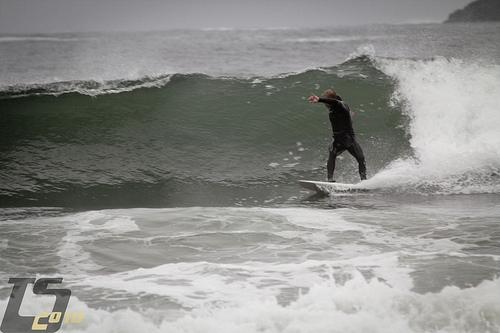What color is the surfboard that the man is standing on? The surfboard is white in color. Find the aspect of the scene that might hold a deeper meaning or emotion in a visual analysis task. The rough ocean water and white water on the waves signify the power and unpredictability of nature, challenging the surfer to find the perfect balance and control. Establish a connection between the main subject and their environment for a story scene setting. A blond man in a black wetsuit expertly riding a large ocean wave on his white surfboard, with the land in the distance and grey skies overhead. Tell a story inspired by the image of the surfer and the large wave in just three sentences. As the enormous wave started to crest behind him, the daring surfer took a deep breath and stood tall on his white surfboard. With perfect balance, he rode the raging water, feeling exhilarated and unstoppable. Amidst the churning ocean, he conquered the wave, proving his mastery over the untamable forces of nature. In a visual entailment task, determine if the man is enjoying the activity. Yes, the man appears to be enjoying surfing the waves. Identify the man's physical features from the image for a character description. The man is light-skinned with blond hair and is wearing a black wetsuit. For a product advertisement, create a catchy slogan promoting the surfboard. Ride the waves with style on our ultra-sleek white surfboard - make every splash count! Choose an accurate referential expression for the main subject in the image. Man balancing on a white surfboard while riding a large wave. What is the unique aspect of this image that offers intrigue or excitement for the viewer? The sheer size of the big ocean wave and the surfer's skillful maneuvering create a sense of excitement and adventure. Compare the surfer's outfit to the surroundings, what is the difference between them? The surfer is wearing a black wetsuit, while he is surrounded by white water and green ocean waves. 